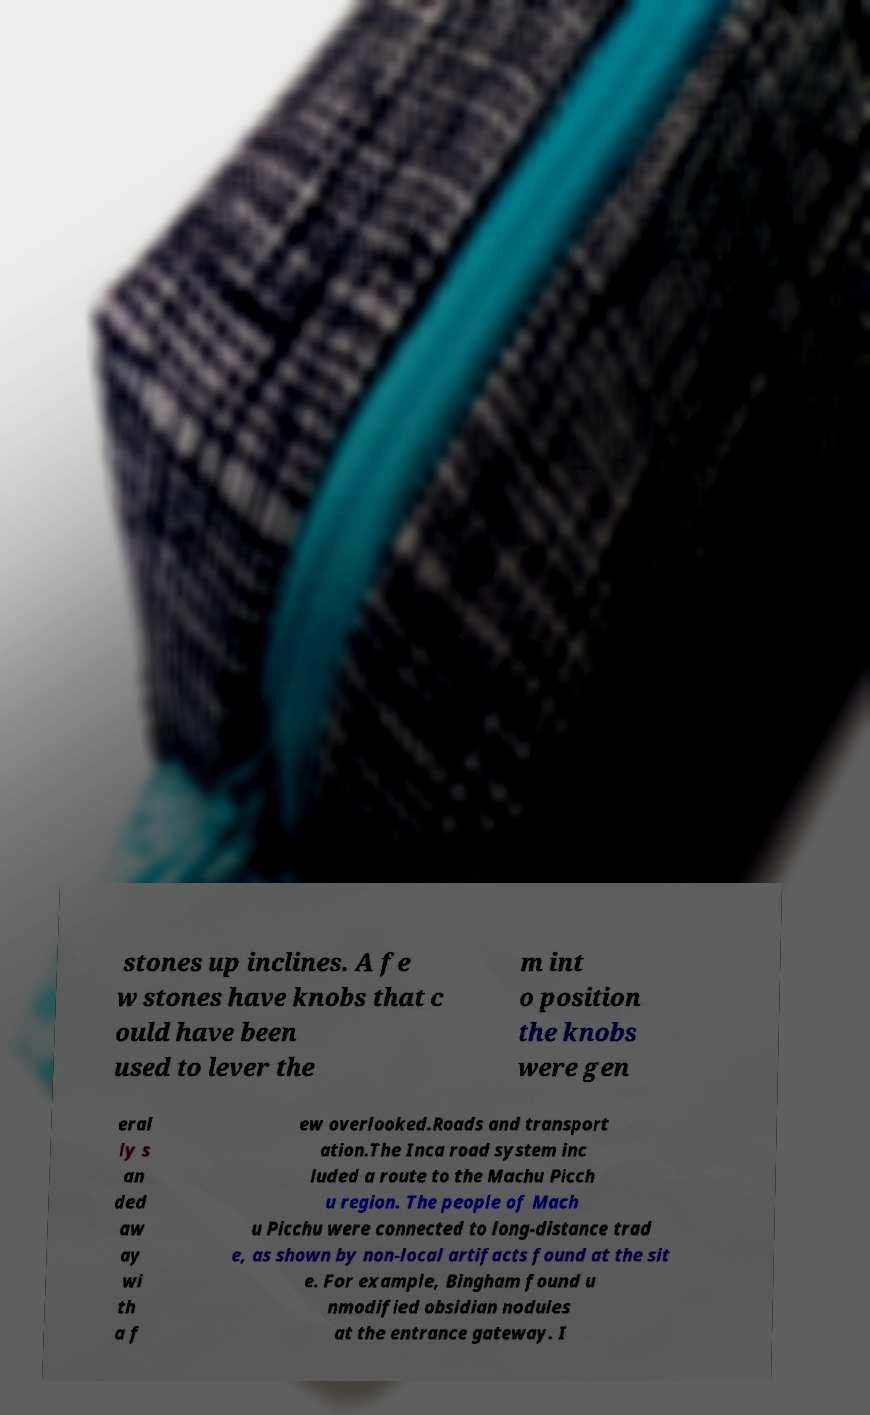For documentation purposes, I need the text within this image transcribed. Could you provide that? stones up inclines. A fe w stones have knobs that c ould have been used to lever the m int o position the knobs were gen eral ly s an ded aw ay wi th a f ew overlooked.Roads and transport ation.The Inca road system inc luded a route to the Machu Picch u region. The people of Mach u Picchu were connected to long-distance trad e, as shown by non-local artifacts found at the sit e. For example, Bingham found u nmodified obsidian nodules at the entrance gateway. I 